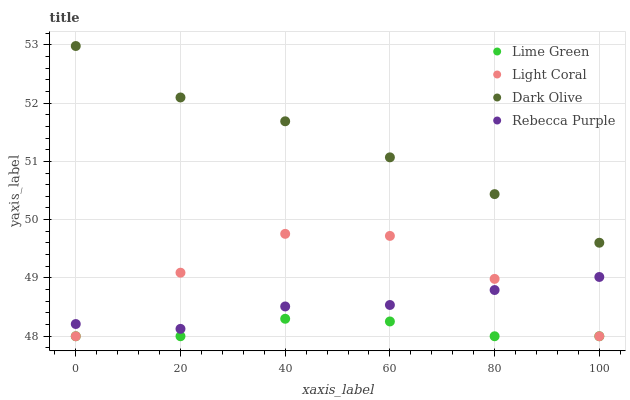Does Lime Green have the minimum area under the curve?
Answer yes or no. Yes. Does Dark Olive have the maximum area under the curve?
Answer yes or no. Yes. Does Dark Olive have the minimum area under the curve?
Answer yes or no. No. Does Lime Green have the maximum area under the curve?
Answer yes or no. No. Is Dark Olive the smoothest?
Answer yes or no. Yes. Is Light Coral the roughest?
Answer yes or no. Yes. Is Lime Green the smoothest?
Answer yes or no. No. Is Lime Green the roughest?
Answer yes or no. No. Does Light Coral have the lowest value?
Answer yes or no. Yes. Does Dark Olive have the lowest value?
Answer yes or no. No. Does Dark Olive have the highest value?
Answer yes or no. Yes. Does Lime Green have the highest value?
Answer yes or no. No. Is Rebecca Purple less than Dark Olive?
Answer yes or no. Yes. Is Rebecca Purple greater than Lime Green?
Answer yes or no. Yes. Does Light Coral intersect Rebecca Purple?
Answer yes or no. Yes. Is Light Coral less than Rebecca Purple?
Answer yes or no. No. Is Light Coral greater than Rebecca Purple?
Answer yes or no. No. Does Rebecca Purple intersect Dark Olive?
Answer yes or no. No. 